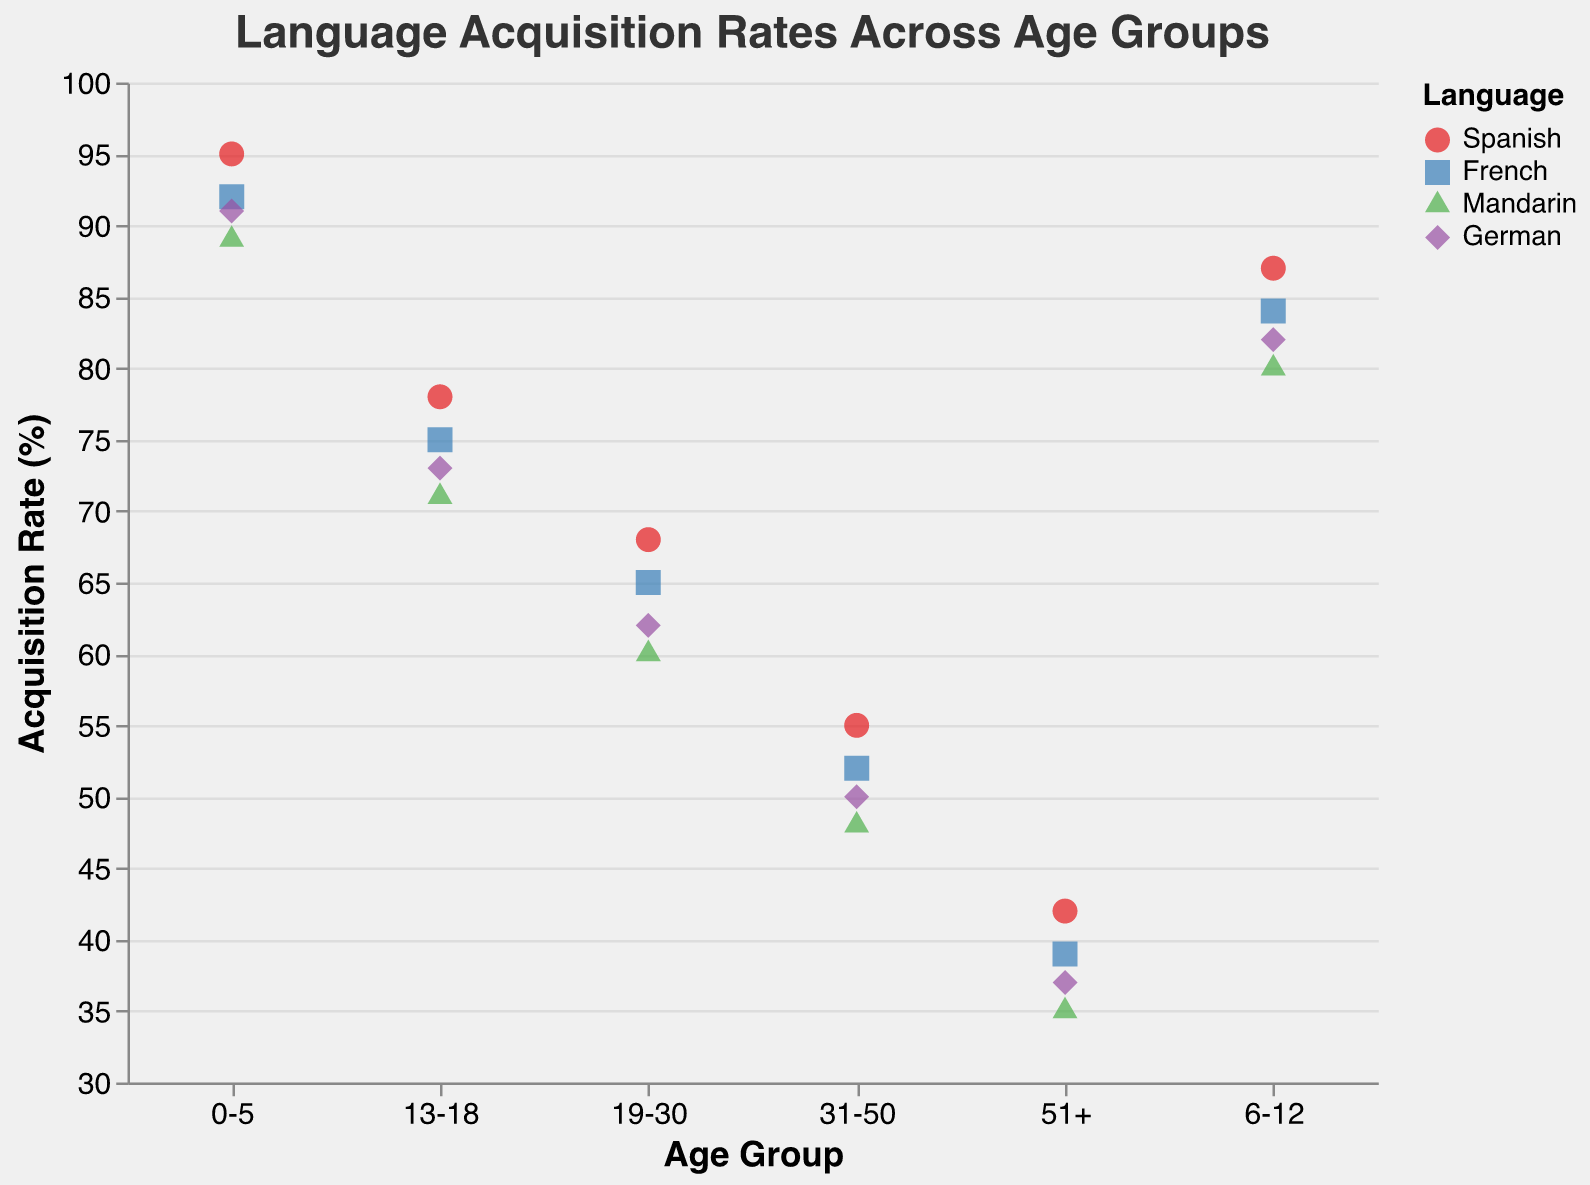What is the title of the plot? The plot's title is located at the top center and reads "Language Acquisition Rates Across Age Groups".
Answer: Language Acquisition Rates Across Age Groups How many age groups are represented in the plot? The x-axis shows the categories for each age group, which are: "0-5", "6-12", "13-18", "19-30", "31-50", and "51+". Counting these categories gives us 6 age groups.
Answer: 6 Which language has the highest acquisition rate in the "19-30" age group? Identify the points for the "19-30" age group on the x-axis, then look for the highest y-value among those points. The highest acquisition rate is for Spanish at 68%.
Answer: Spanish What is the acquisition rate for Mandarin in the "31-50" age group? Locate the points on the plot corresponding to the "31-50" age group, then identify the point representing Mandarin. The acquisition rate is marked as 48%.
Answer: 48% Compare the acquisition rates of German between the "6-12" and "51+" age groups. Find the points representing German for each age group. In the "6-12" group, the rate is 82%. In the "51+" group, the rate is 37%. Compare them.
Answer: 82% is higher than 37% What is the average acquisition rate for French across all age groups? First, sum the acquisition rates for French in all age groups: 92 + 84 + 75 + 65 + 52 + 39 = 407. Next, divide by the number of age groups (6): 407 / 6 ≈ 67.83.
Answer: 67.83% Which age group shows the greatest decline in acquisition rates for Mandarin compared to the previous age group? Examine the acquisition rates for Mandarin in each age group: 89 (0-5), 80 (6-12), 71 (13-18), 60 (19-30), 48 (31-50), and 35 (51+). Calculate the differences: 9 (0-5 to 6-12), 9 (6-12 to 13-18), 11 (13-18 to 19-30), 12 (19-30 to 31-50), and 13 (31-50 to 51+). The greatest decline is from 31-50 to 51+.
Answer: 31-50 to 51+ What shape and color are used to represent Spanish in the plot? The legend indicates that Spanish is represented by a red circle.
Answer: Red circle Which age group has the lowest overall language acquisition rates? Examine the points on the plot across different age groups. The "51+" age group shows the lowest points, indicating the lowest overall rates.
Answer: 51+ What trend can you observe in language acquisition rates as people age? The points generally decrease as you move from left to right along the x-axis, indicating that acquisition rates tend to decline with age.
Answer: Decline with age 